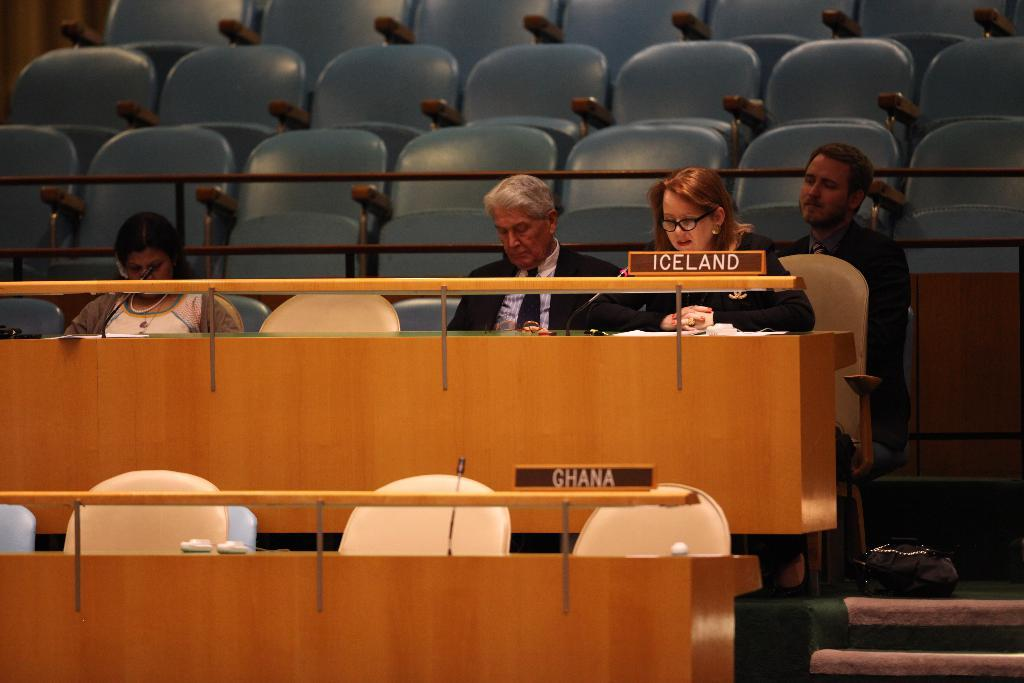<image>
Share a concise interpretation of the image provided. Several politicians sit behind an Iceland name plate during a conference. 